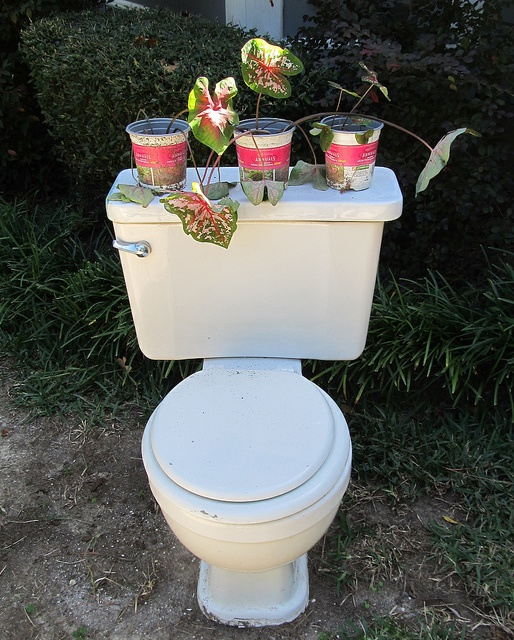Describe the objects in this image and their specific colors. I can see toilet in black, lightgray, lightblue, and darkgray tones, potted plant in black, darkgreen, gray, and darkgray tones, potted plant in black, olive, darkgray, salmon, and gray tones, and potted plant in black, lightgray, gray, and darkgreen tones in this image. 